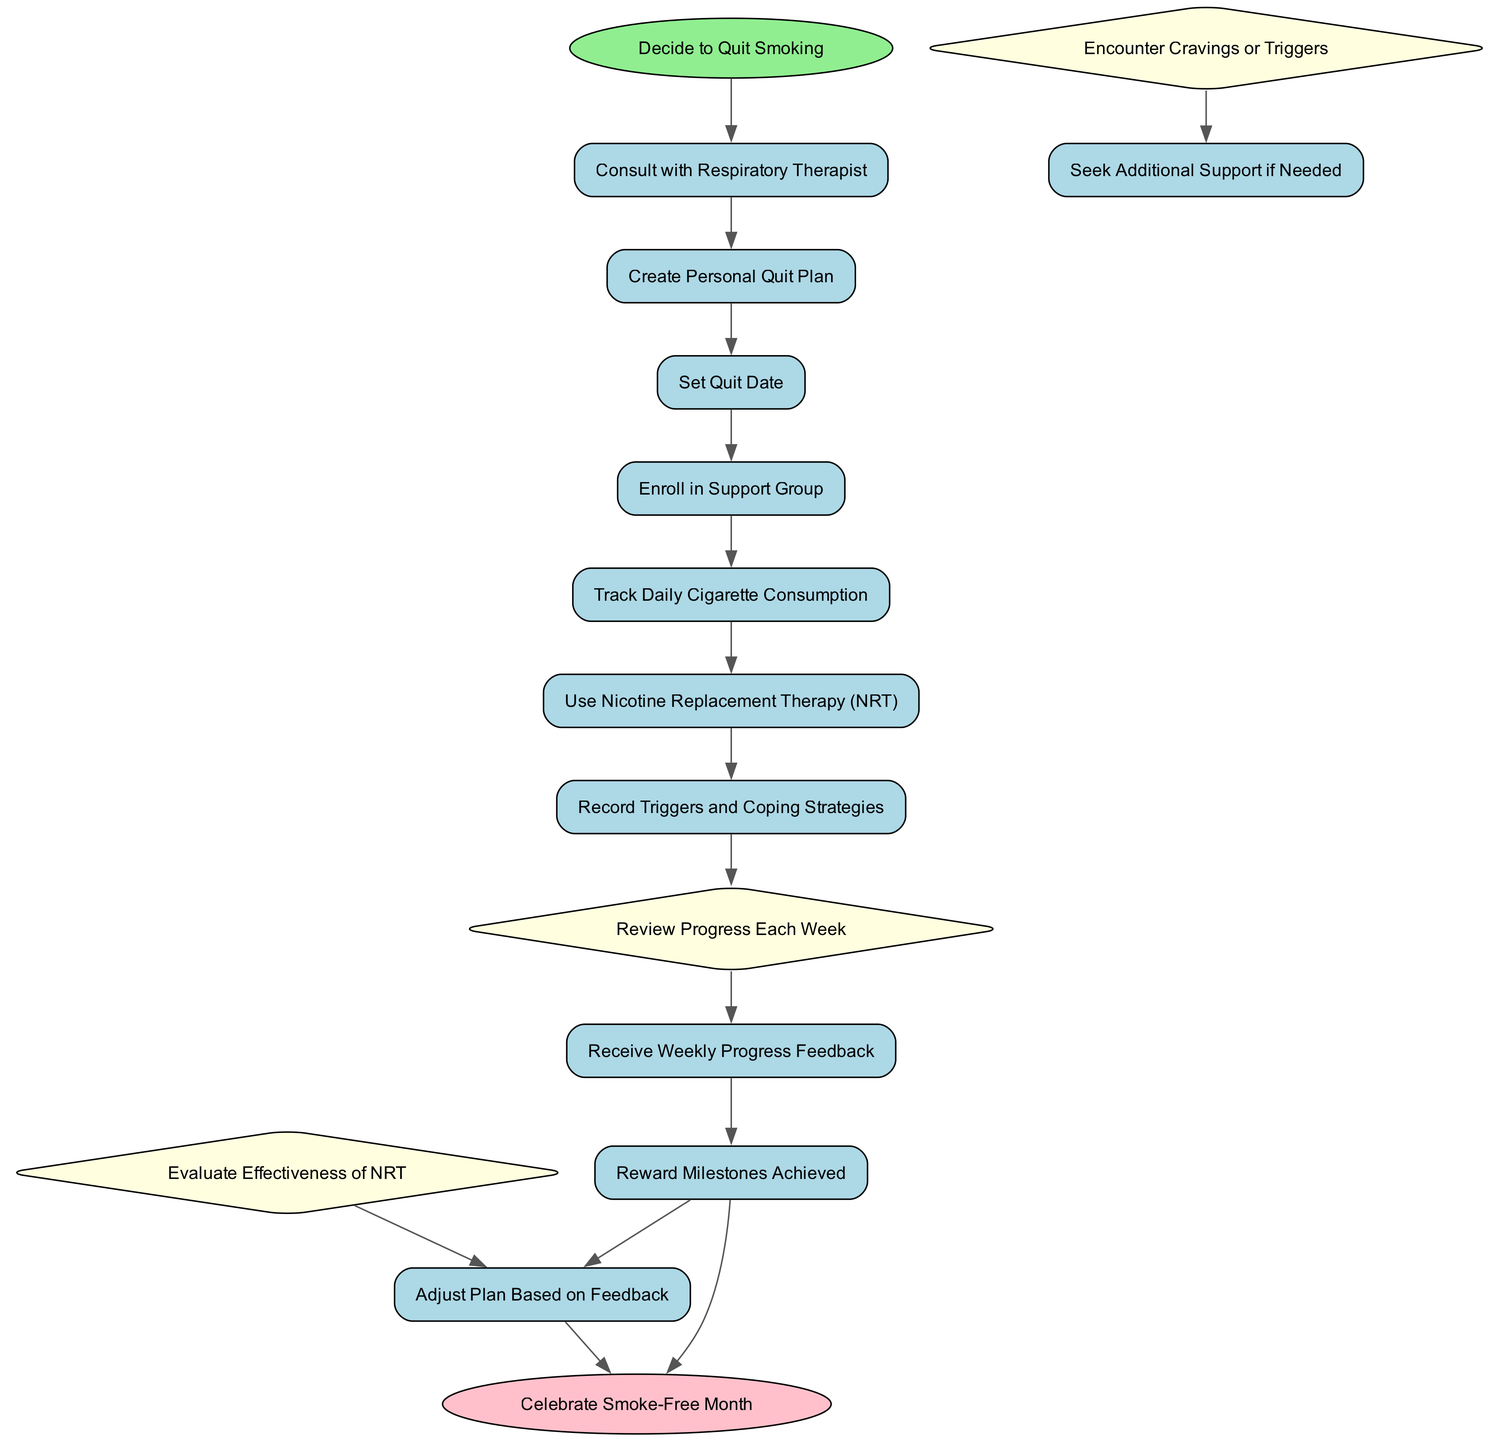What is the initial step in the process? The initial step is "Decide to Quit Smoking," which is highlighted as the starting point in the diagram.
Answer: Decide to Quit Smoking How many decision points are there in the diagram? There are three decision points labeled in the diagram, which are specific moments where choices or evaluations occur.
Answer: 3 Which activity follows "Consult with Respiratory Therapist"? The activity that directly follows "Consult with Respiratory Therapist" is "Create Personal Quit Plan," as it is the next step in the flow of activities.
Answer: Create Personal Quit Plan What happens after "Receive Weekly Progress Feedback"? After receiving feedback, the process can either lead to "Reward Milestones Achieved" or involve adjusting the plan based on that feedback, indicating different paths depending on the outcome.
Answer: Reward Milestones Achieved or Adjust Plan Based on Feedback What do you do if you encounter cravings or triggers? If cravings or triggers are encountered, the diagram indicates that you should "Seek Additional Support if Needed," showing a response strategy to cravings.
Answer: Seek Additional Support if Needed Which activity has an optional outcome? The "Reward Milestones Achieved" activity includes an optional outcome leading directly to "Celebrate Smoke-Free Month," indicating a motivational step that can occur at different times.
Answer: Reward Milestones Achieved How many total activities are included in the diagram? The diagram includes a total of thirteen activities, encompassing all actions and steps related to quitting smoking.
Answer: 13 What is the final outcome of the process? The final outcome represented in the diagram is "Celebrate Smoke-Free Month," which signifies the achievement of being smoke-free for a specified duration.
Answer: Celebrate Smoke-Free Month 